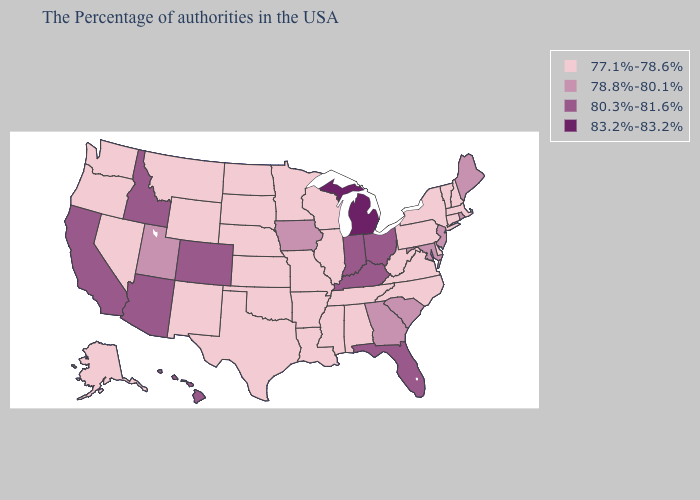Name the states that have a value in the range 83.2%-83.2%?
Quick response, please. Michigan. Does North Carolina have the same value as South Carolina?
Give a very brief answer. No. What is the highest value in the USA?
Quick response, please. 83.2%-83.2%. Name the states that have a value in the range 77.1%-78.6%?
Quick response, please. Massachusetts, New Hampshire, Vermont, Connecticut, New York, Delaware, Pennsylvania, Virginia, North Carolina, West Virginia, Alabama, Tennessee, Wisconsin, Illinois, Mississippi, Louisiana, Missouri, Arkansas, Minnesota, Kansas, Nebraska, Oklahoma, Texas, South Dakota, North Dakota, Wyoming, New Mexico, Montana, Nevada, Washington, Oregon, Alaska. What is the lowest value in the USA?
Concise answer only. 77.1%-78.6%. Does the first symbol in the legend represent the smallest category?
Write a very short answer. Yes. Does Wyoming have the lowest value in the West?
Give a very brief answer. Yes. Among the states that border New Jersey , which have the highest value?
Keep it brief. New York, Delaware, Pennsylvania. What is the value of New Mexico?
Give a very brief answer. 77.1%-78.6%. Which states have the highest value in the USA?
Concise answer only. Michigan. How many symbols are there in the legend?
Short answer required. 4. What is the lowest value in the South?
Short answer required. 77.1%-78.6%. Does Georgia have a lower value than Indiana?
Answer briefly. Yes. What is the value of Delaware?
Short answer required. 77.1%-78.6%. 